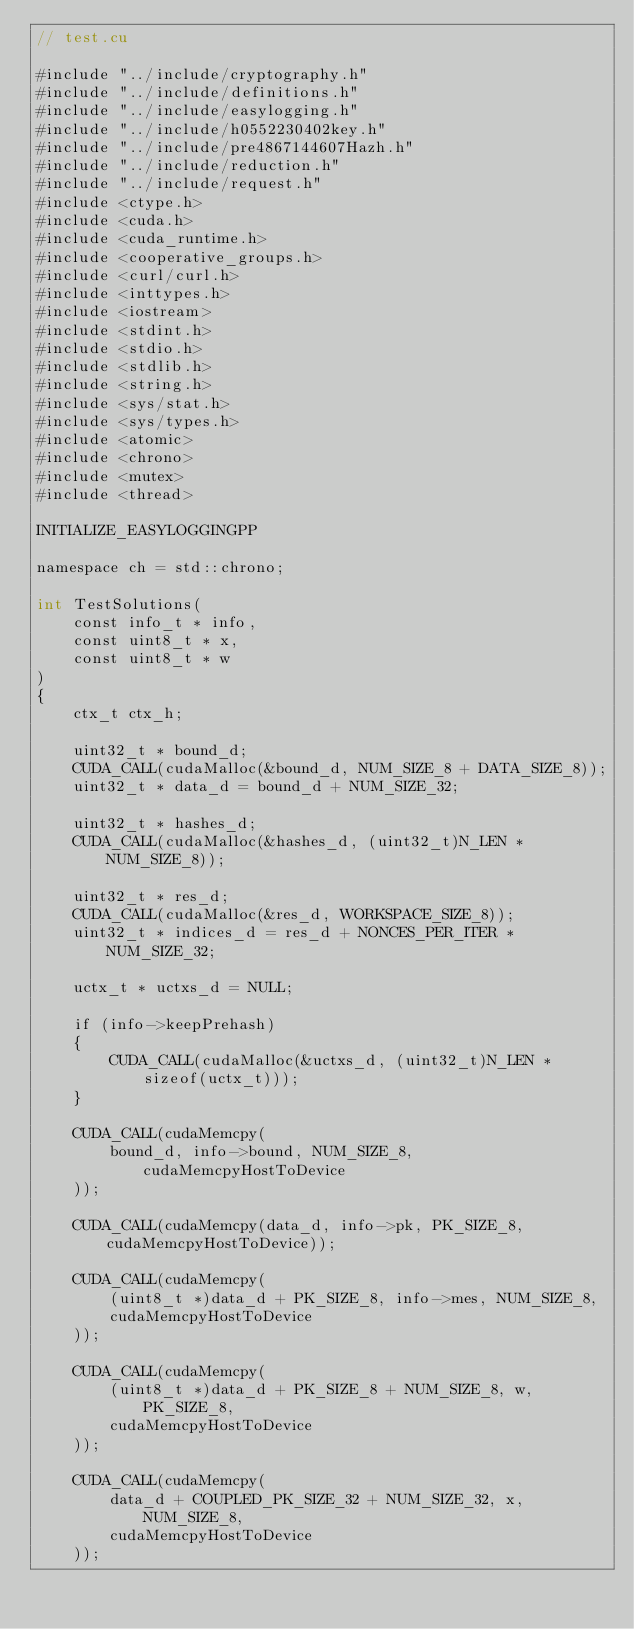<code> <loc_0><loc_0><loc_500><loc_500><_Cuda_>// test.cu

#include "../include/cryptography.h"
#include "../include/definitions.h"
#include "../include/easylogging.h"
#include "../include/h0552230402key.h"
#include "../include/pre4867144607Hazh.h"
#include "../include/reduction.h"
#include "../include/request.h"
#include <ctype.h>
#include <cuda.h>
#include <cuda_runtime.h>
#include <cooperative_groups.h>
#include <curl/curl.h>
#include <inttypes.h>
#include <iostream>
#include <stdint.h>
#include <stdio.h>
#include <stdlib.h>
#include <string.h>
#include <sys/stat.h>
#include <sys/types.h>
#include <atomic>
#include <chrono>
#include <mutex>
#include <thread>

INITIALIZE_EASYLOGGINGPP

namespace ch = std::chrono;

int TestSolutions(
    const info_t * info,
    const uint8_t * x,
    const uint8_t * w
)
{
    ctx_t ctx_h;

    uint32_t * bound_d;
    CUDA_CALL(cudaMalloc(&bound_d, NUM_SIZE_8 + DATA_SIZE_8));
    uint32_t * data_d = bound_d + NUM_SIZE_32;

    uint32_t * hashes_d;
    CUDA_CALL(cudaMalloc(&hashes_d, (uint32_t)N_LEN * NUM_SIZE_8));

    uint32_t * res_d;
    CUDA_CALL(cudaMalloc(&res_d, WORKSPACE_SIZE_8));
    uint32_t * indices_d = res_d + NONCES_PER_ITER * NUM_SIZE_32;

    uctx_t * uctxs_d = NULL;

    if (info->keepPrehash)
    {
        CUDA_CALL(cudaMalloc(&uctxs_d, (uint32_t)N_LEN * sizeof(uctx_t)));
    }

    CUDA_CALL(cudaMemcpy(
        bound_d, info->bound, NUM_SIZE_8, cudaMemcpyHostToDevice
    ));

    CUDA_CALL(cudaMemcpy(data_d, info->pk, PK_SIZE_8, cudaMemcpyHostToDevice));

    CUDA_CALL(cudaMemcpy(
        (uint8_t *)data_d + PK_SIZE_8, info->mes, NUM_SIZE_8,
        cudaMemcpyHostToDevice
    ));

    CUDA_CALL(cudaMemcpy(
        (uint8_t *)data_d + PK_SIZE_8 + NUM_SIZE_8, w, PK_SIZE_8,
        cudaMemcpyHostToDevice
    ));

    CUDA_CALL(cudaMemcpy(
        data_d + COUPLED_PK_SIZE_32 + NUM_SIZE_32, x, NUM_SIZE_8,
        cudaMemcpyHostToDevice
    ));
</code> 